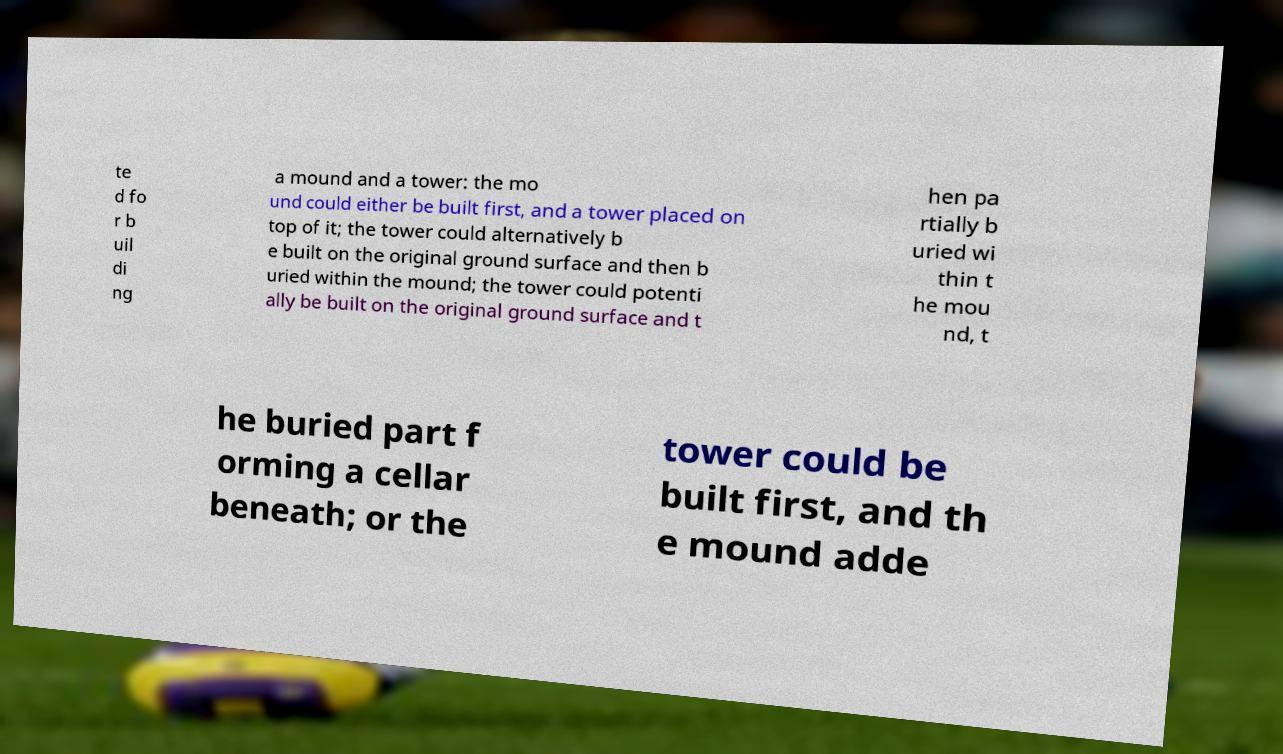Please read and relay the text visible in this image. What does it say? te d fo r b uil di ng a mound and a tower: the mo und could either be built first, and a tower placed on top of it; the tower could alternatively b e built on the original ground surface and then b uried within the mound; the tower could potenti ally be built on the original ground surface and t hen pa rtially b uried wi thin t he mou nd, t he buried part f orming a cellar beneath; or the tower could be built first, and th e mound adde 